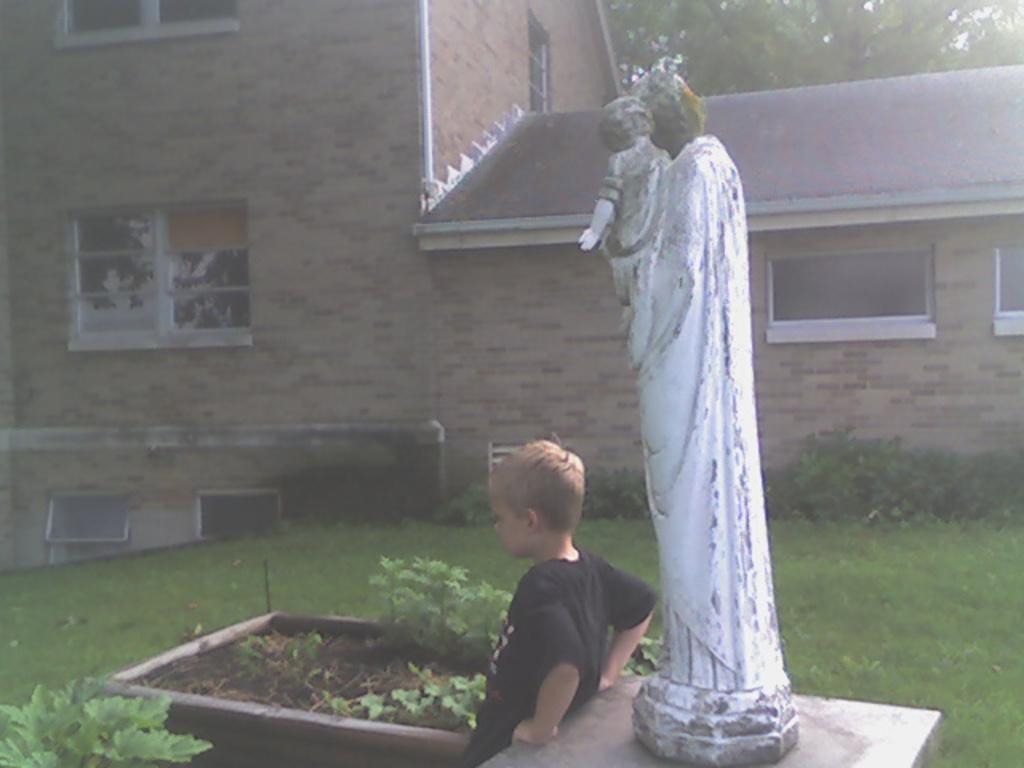How would you summarize this image in a sentence or two? There is a statue on a stand. Near to that a boy is standing. There is a pot with plants. Also there is grass lawn. In the back there is a building with windows. In the background there are trees. 